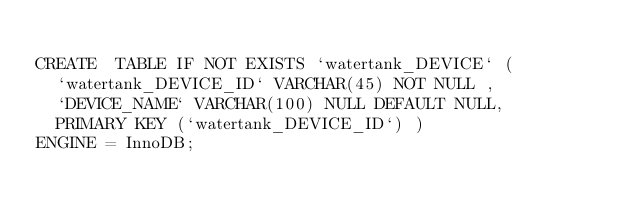<code> <loc_0><loc_0><loc_500><loc_500><_SQL_>
CREATE  TABLE IF NOT EXISTS `watertank_DEVICE` (
  `watertank_DEVICE_ID` VARCHAR(45) NOT NULL ,
  `DEVICE_NAME` VARCHAR(100) NULL DEFAULT NULL,
  PRIMARY KEY (`watertank_DEVICE_ID`) )
ENGINE = InnoDB;




</code> 